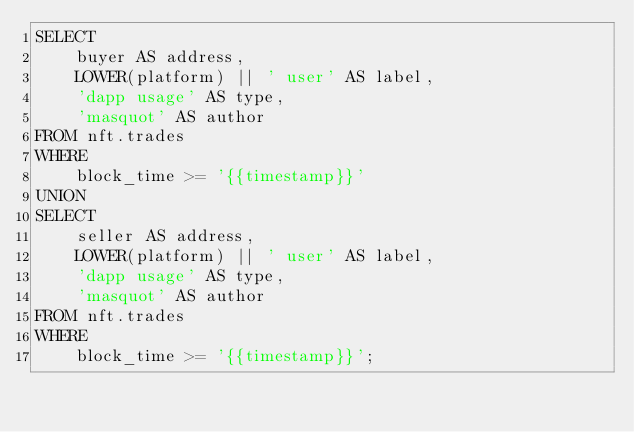<code> <loc_0><loc_0><loc_500><loc_500><_SQL_>SELECT
    buyer AS address,
    LOWER(platform) || ' user' AS label,
    'dapp usage' AS type,
    'masquot' AS author
FROM nft.trades
WHERE
    block_time >= '{{timestamp}}'
UNION
SELECT
    seller AS address,
    LOWER(platform) || ' user' AS label,
    'dapp usage' AS type,
    'masquot' AS author
FROM nft.trades
WHERE
    block_time >= '{{timestamp}}';
</code> 